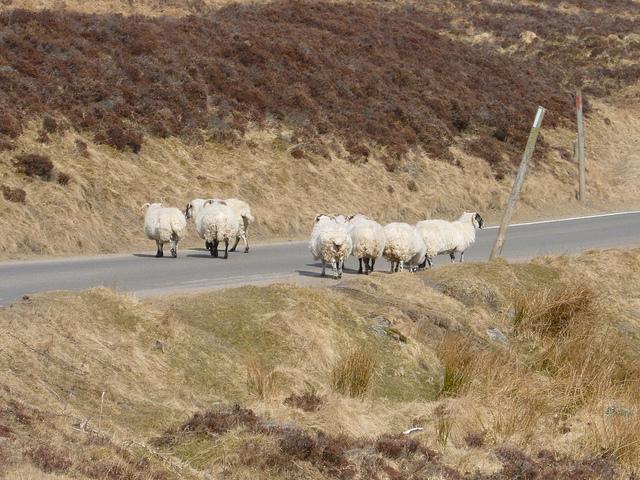What is the fur of the animal in this image commonly used for?
Select the accurate answer and provide justification: `Answer: choice
Rationale: srationale.`
Options: Carpets, cars, yard work, weapons. Answer: carpets.
Rationale: The animals in the image are sheep. their fur is too soft to be used for yard work, weapons, or cars. 